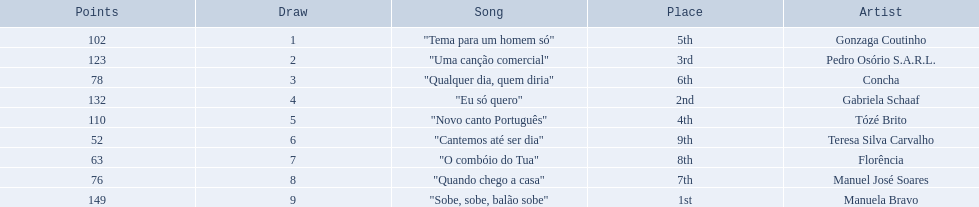Is there a song called eu so quero in the table? "Eu só quero". Who sang that song? Gabriela Schaaf. 